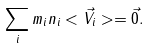Convert formula to latex. <formula><loc_0><loc_0><loc_500><loc_500>\sum _ { i } m _ { i } n _ { i } < \vec { V } _ { i } > = \vec { 0 } .</formula> 